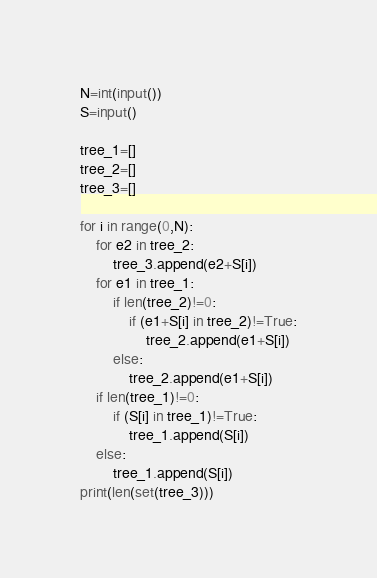Convert code to text. <code><loc_0><loc_0><loc_500><loc_500><_Python_>
N=int(input())
S=input()

tree_1=[]
tree_2=[]
tree_3=[]

for i in range(0,N):
    for e2 in tree_2:
        tree_3.append(e2+S[i])
    for e1 in tree_1:
        if len(tree_2)!=0:
            if (e1+S[i] in tree_2)!=True:
                tree_2.append(e1+S[i])
        else:
            tree_2.append(e1+S[i])
    if len(tree_1)!=0:
        if (S[i] in tree_1)!=True:
            tree_1.append(S[i])
    else:
        tree_1.append(S[i])
print(len(set(tree_3)))
</code> 